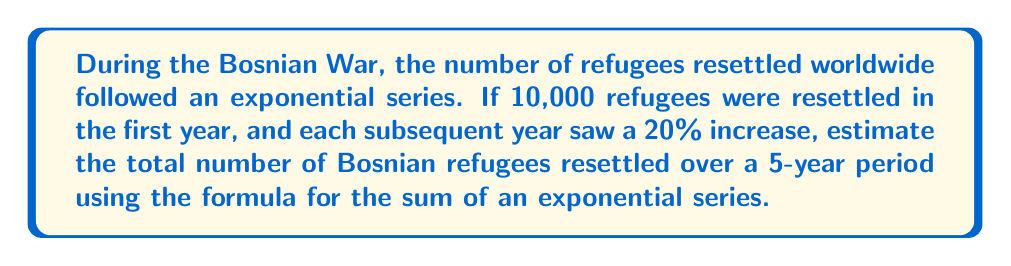Give your solution to this math problem. Let's approach this step-by-step:

1) The exponential series for the number of refugees resettled each year can be represented as:
   $a, ar, ar^2, ar^3, ar^4$
   where $a = 10,000$ (initial number) and $r = 1.20$ (20% increase each year)

2) The sum of this geometric series is given by the formula:
   $$S_n = a\frac{1-r^n}{1-r}$$
   where $n = 5$ (5-year period)

3) Substituting our values:
   $$S_5 = 10,000 \frac{1-(1.20)^5}{1-1.20}$$

4) Calculate $(1.20)^5$:
   $$(1.20)^5 = 2.4883$$

5) Simplify the numerator:
   $$S_5 = 10,000 \frac{1-2.4883}{-0.20}$$
   $$S_5 = 10,000 \frac{-1.4883}{-0.20}$$

6) Divide:
   $$S_5 = 10,000 * 7.4415$$

7) Calculate the final result:
   $$S_5 = 74,415$$

Therefore, the estimated total number of Bosnian refugees resettled over the 5-year period is approximately 74,415.
Answer: 74,415 refugees 